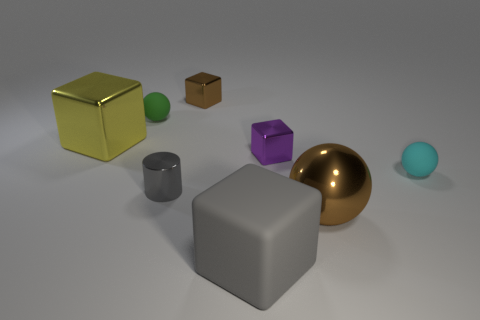What shape is the object that is in front of the small gray metal cylinder and on the right side of the purple metal object?
Your answer should be very brief. Sphere. How many small things are either cyan spheres or gray metallic things?
Offer a terse response. 2. Are there an equal number of tiny shiny objects that are in front of the tiny brown object and gray things on the left side of the tiny metallic cylinder?
Make the answer very short. No. How many other things are the same color as the big metal cube?
Ensure brevity in your answer.  0. Are there the same number of yellow objects that are behind the tiny green matte sphere and small rubber objects?
Your response must be concise. No. Do the brown sphere and the brown shiny block have the same size?
Give a very brief answer. No. What is the material of the object that is on the right side of the big rubber cube and in front of the small gray metal cylinder?
Keep it short and to the point. Metal. What number of tiny gray shiny things have the same shape as the cyan matte object?
Make the answer very short. 0. There is a brown object that is in front of the tiny green object; what material is it?
Give a very brief answer. Metal. Is the number of green spheres to the right of the brown metallic cube less than the number of red rubber cylinders?
Your answer should be very brief. No. 